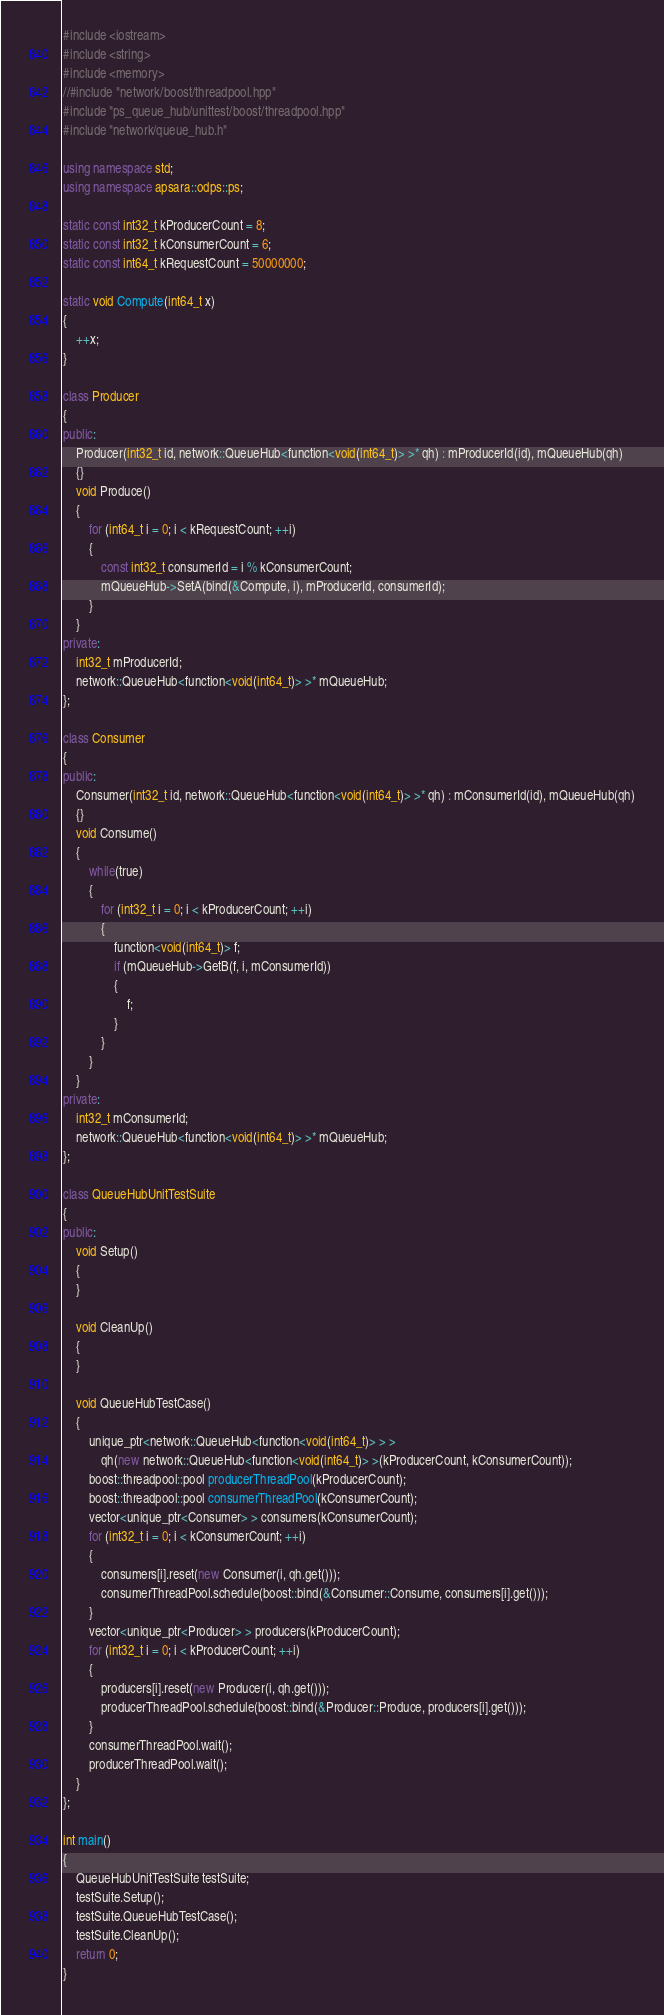<code> <loc_0><loc_0><loc_500><loc_500><_C++_>#include <iostream>
#include <string>
#include <memory>
//#include "network/boost/threadpool.hpp"
#include "ps_queue_hub/unittest/boost/threadpool.hpp"
#include "network/queue_hub.h"

using namespace std;
using namespace apsara::odps::ps;

static const int32_t kProducerCount = 8;
static const int32_t kConsumerCount = 6;
static const int64_t kRequestCount = 50000000;

static void Compute(int64_t x)
{
    ++x;
}

class Producer
{
public:
    Producer(int32_t id, network::QueueHub<function<void(int64_t)> >* qh) : mProducerId(id), mQueueHub(qh)
    {}
    void Produce()
    {
        for (int64_t i = 0; i < kRequestCount; ++i)
        {
            const int32_t consumerId = i % kConsumerCount;
            mQueueHub->SetA(bind(&Compute, i), mProducerId, consumerId);
        }
    }
private:
    int32_t mProducerId;
    network::QueueHub<function<void(int64_t)> >* mQueueHub;
};

class Consumer
{
public:
    Consumer(int32_t id, network::QueueHub<function<void(int64_t)> >* qh) : mConsumerId(id), mQueueHub(qh)
    {}
    void Consume()
    {
        while(true)
        {
            for (int32_t i = 0; i < kProducerCount; ++i)
            {
                function<void(int64_t)> f;
                if (mQueueHub->GetB(f, i, mConsumerId))
                {
                    f;
                }
            }
        }
    }
private:
    int32_t mConsumerId;
    network::QueueHub<function<void(int64_t)> >* mQueueHub;
};

class QueueHubUnitTestSuite
{
public:
    void Setup()
    {
    }

    void CleanUp()
    {
    }

    void QueueHubTestCase()
    {
        unique_ptr<network::QueueHub<function<void(int64_t)> > >
            qh(new network::QueueHub<function<void(int64_t)> >(kProducerCount, kConsumerCount));
        boost::threadpool::pool producerThreadPool(kProducerCount);
        boost::threadpool::pool consumerThreadPool(kConsumerCount);
        vector<unique_ptr<Consumer> > consumers(kConsumerCount);
        for (int32_t i = 0; i < kConsumerCount; ++i)
        {
            consumers[i].reset(new Consumer(i, qh.get()));
            consumerThreadPool.schedule(boost::bind(&Consumer::Consume, consumers[i].get()));
        }
        vector<unique_ptr<Producer> > producers(kProducerCount);
        for (int32_t i = 0; i < kProducerCount; ++i)
        {
            producers[i].reset(new Producer(i, qh.get()));
            producerThreadPool.schedule(boost::bind(&Producer::Produce, producers[i].get()));
        }
        consumerThreadPool.wait();
        producerThreadPool.wait();
    }
};

int main()
{
    QueueHubUnitTestSuite testSuite;
    testSuite.Setup();
    testSuite.QueueHubTestCase();
    testSuite.CleanUp();
    return 0;
}
</code> 